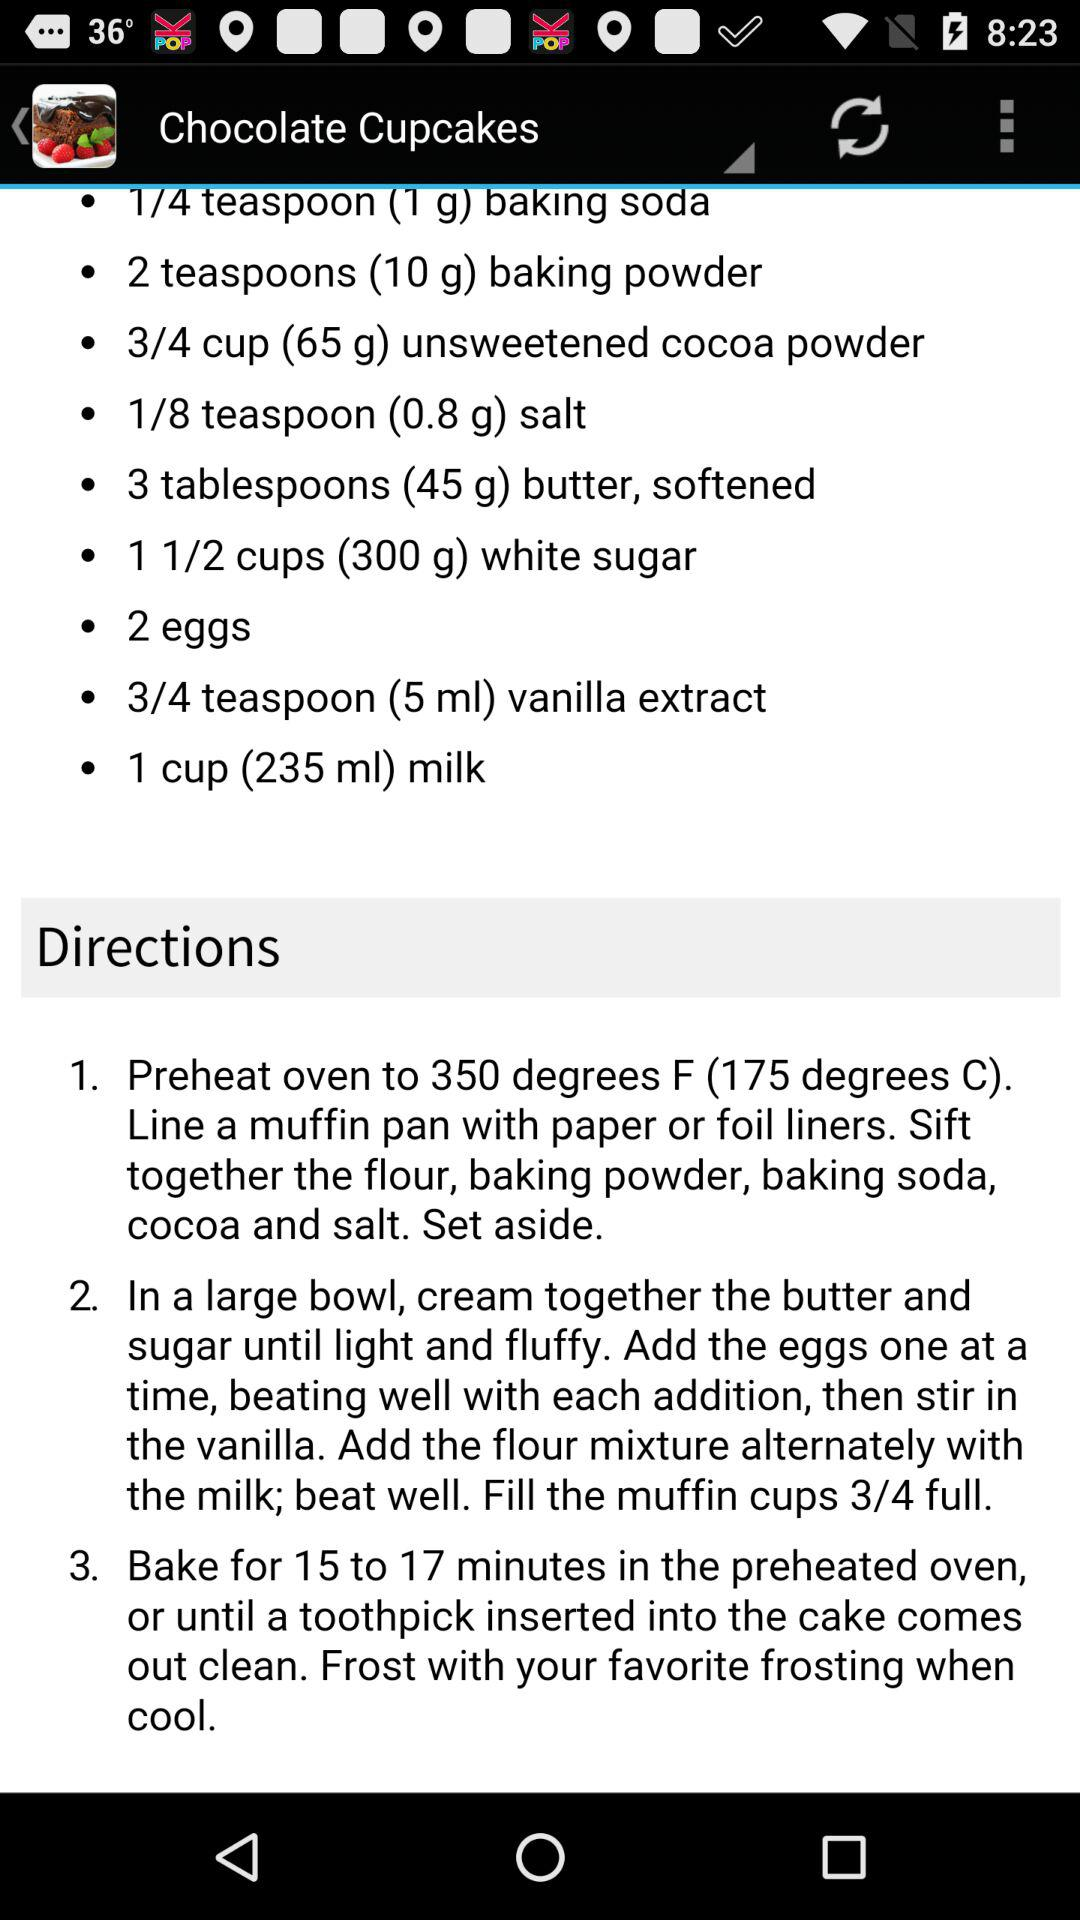How many eggs are needed for the "Chocolate Cupcakes"? The number of eggs needed for the "Chocolate Cupcakes" is 2. 